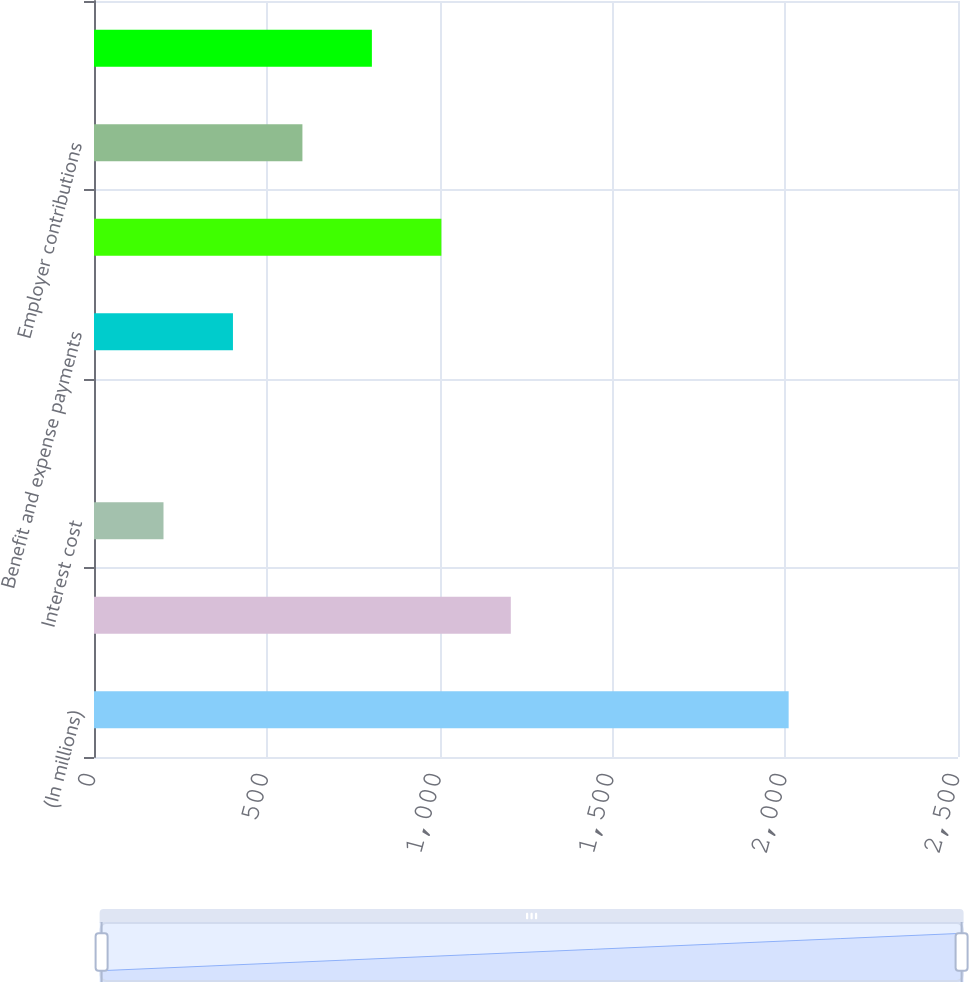Convert chart. <chart><loc_0><loc_0><loc_500><loc_500><bar_chart><fcel>(In millions)<fcel>Benefit obligation-beginning<fcel>Interest cost<fcel>Actuarial (gain) loss<fcel>Benefit and expense payments<fcel>Benefit obligation-end of<fcel>Employer contributions<fcel>Noncurrent liabilities<nl><fcel>2010<fcel>1206.04<fcel>201.09<fcel>0.1<fcel>402.08<fcel>1005.05<fcel>603.07<fcel>804.06<nl></chart> 